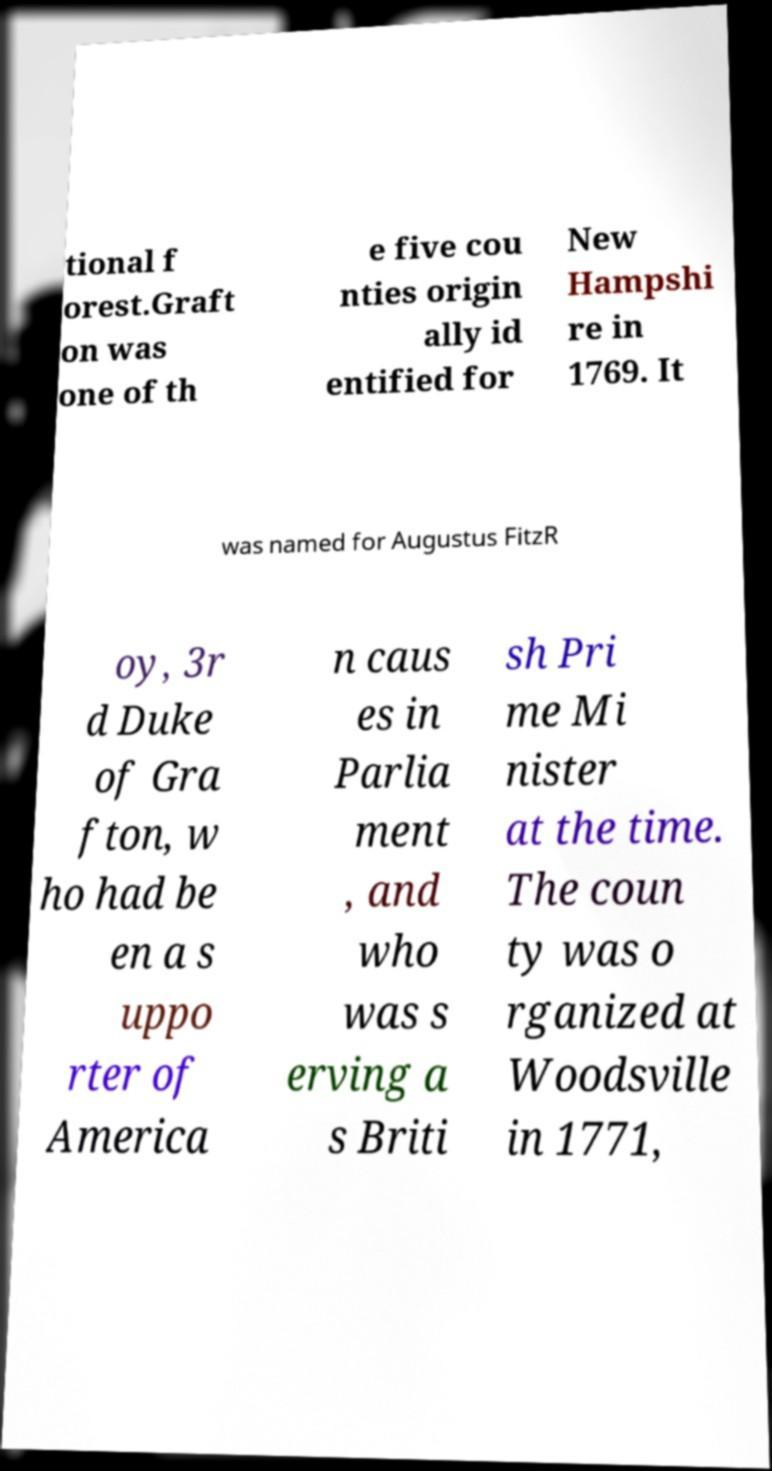Please read and relay the text visible in this image. What does it say? tional f orest.Graft on was one of th e five cou nties origin ally id entified for New Hampshi re in 1769. It was named for Augustus FitzR oy, 3r d Duke of Gra fton, w ho had be en a s uppo rter of America n caus es in Parlia ment , and who was s erving a s Briti sh Pri me Mi nister at the time. The coun ty was o rganized at Woodsville in 1771, 